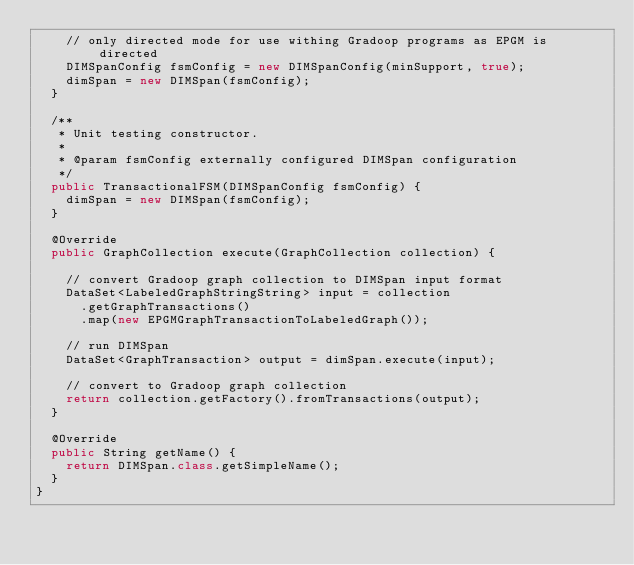Convert code to text. <code><loc_0><loc_0><loc_500><loc_500><_Java_>    // only directed mode for use withing Gradoop programs as EPGM is directed
    DIMSpanConfig fsmConfig = new DIMSpanConfig(minSupport, true);
    dimSpan = new DIMSpan(fsmConfig);
  }

  /**
   * Unit testing constructor.
   *
   * @param fsmConfig externally configured DIMSpan configuration
   */
  public TransactionalFSM(DIMSpanConfig fsmConfig) {
    dimSpan = new DIMSpan(fsmConfig);
  }

  @Override
  public GraphCollection execute(GraphCollection collection) {

    // convert Gradoop graph collection to DIMSpan input format
    DataSet<LabeledGraphStringString> input = collection
      .getGraphTransactions()
      .map(new EPGMGraphTransactionToLabeledGraph());

    // run DIMSpan
    DataSet<GraphTransaction> output = dimSpan.execute(input);

    // convert to Gradoop graph collection
    return collection.getFactory().fromTransactions(output);
  }

  @Override
  public String getName() {
    return DIMSpan.class.getSimpleName();
  }
}
</code> 